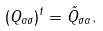<formula> <loc_0><loc_0><loc_500><loc_500>( Q _ { \alpha \sigma } ) ^ { t } = \tilde { Q } _ { \sigma \alpha } .</formula> 